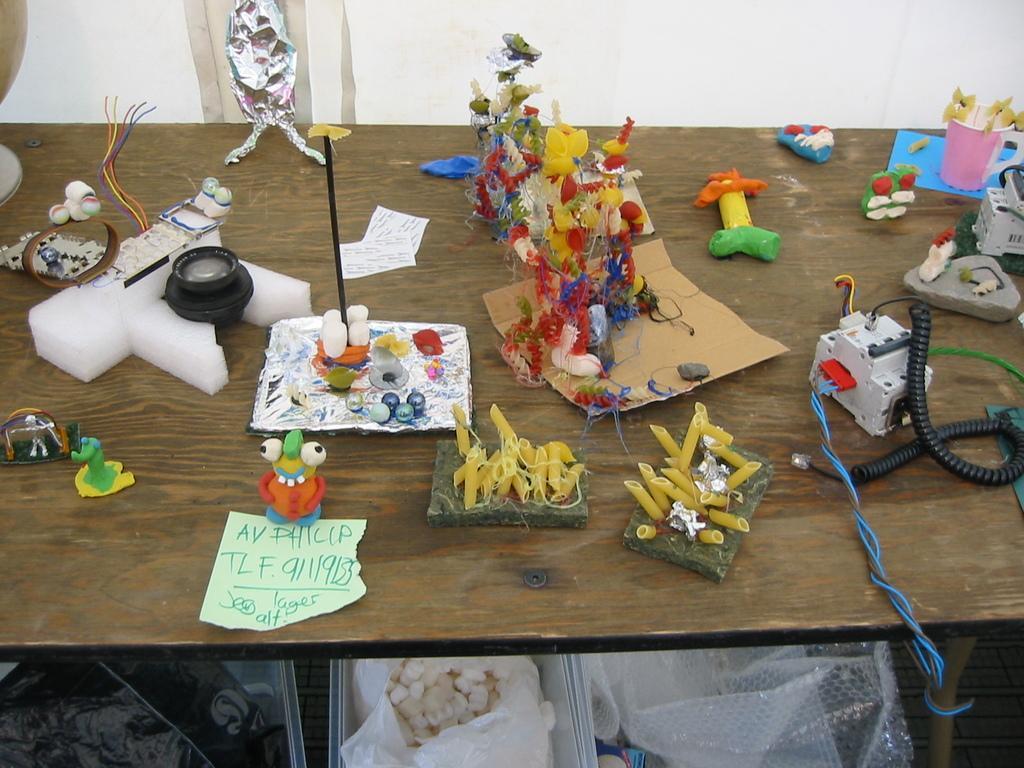Describe this image in one or two sentences. In this picture we can see a table and on table we have camera, some toys, spring, motor and below this table we have plastic cover, cotton. 